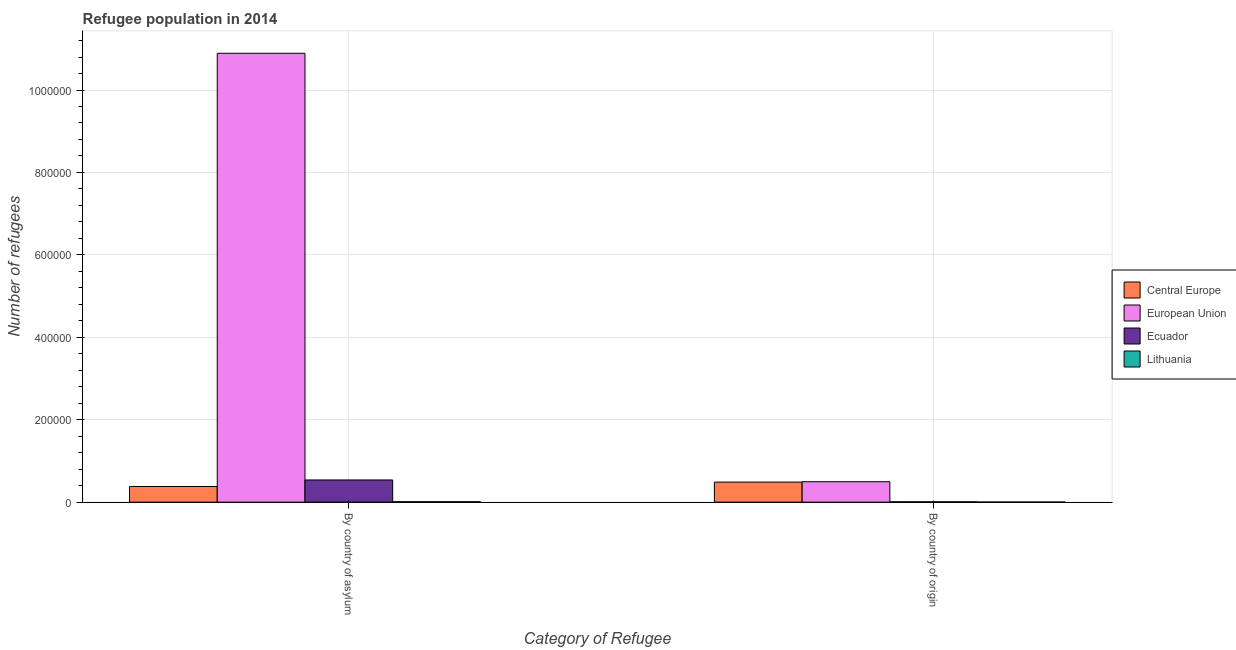How many groups of bars are there?
Your response must be concise. 2. Are the number of bars per tick equal to the number of legend labels?
Offer a terse response. Yes. Are the number of bars on each tick of the X-axis equal?
Your response must be concise. Yes. What is the label of the 2nd group of bars from the left?
Give a very brief answer. By country of origin. What is the number of refugees by country of asylum in Central Europe?
Make the answer very short. 3.80e+04. Across all countries, what is the maximum number of refugees by country of asylum?
Offer a very short reply. 1.09e+06. Across all countries, what is the minimum number of refugees by country of origin?
Give a very brief answer. 183. In which country was the number of refugees by country of asylum minimum?
Make the answer very short. Lithuania. What is the total number of refugees by country of origin in the graph?
Make the answer very short. 9.92e+04. What is the difference between the number of refugees by country of asylum in Central Europe and that in Lithuania?
Offer a very short reply. 3.70e+04. What is the difference between the number of refugees by country of origin in Ecuador and the number of refugees by country of asylum in Central Europe?
Your answer should be compact. -3.72e+04. What is the average number of refugees by country of asylum per country?
Provide a short and direct response. 2.95e+05. What is the difference between the number of refugees by country of asylum and number of refugees by country of origin in Lithuania?
Your answer should be very brief. 824. What is the ratio of the number of refugees by country of asylum in European Union to that in Central Europe?
Make the answer very short. 28.67. Is the number of refugees by country of origin in Central Europe less than that in European Union?
Your answer should be compact. Yes. What does the 1st bar from the left in By country of origin represents?
Your response must be concise. Central Europe. What does the 4th bar from the right in By country of asylum represents?
Provide a short and direct response. Central Europe. Are all the bars in the graph horizontal?
Offer a very short reply. No. How many countries are there in the graph?
Offer a terse response. 4. Are the values on the major ticks of Y-axis written in scientific E-notation?
Your answer should be very brief. No. Does the graph contain any zero values?
Provide a short and direct response. No. Does the graph contain grids?
Offer a terse response. Yes. What is the title of the graph?
Provide a succinct answer. Refugee population in 2014. What is the label or title of the X-axis?
Provide a succinct answer. Category of Refugee. What is the label or title of the Y-axis?
Your answer should be very brief. Number of refugees. What is the Number of refugees of Central Europe in By country of asylum?
Ensure brevity in your answer.  3.80e+04. What is the Number of refugees of European Union in By country of asylum?
Provide a short and direct response. 1.09e+06. What is the Number of refugees in Ecuador in By country of asylum?
Your answer should be compact. 5.38e+04. What is the Number of refugees of Lithuania in By country of asylum?
Offer a very short reply. 1007. What is the Number of refugees in Central Europe in By country of origin?
Your response must be concise. 4.87e+04. What is the Number of refugees of European Union in By country of origin?
Provide a short and direct response. 4.96e+04. What is the Number of refugees of Ecuador in By country of origin?
Make the answer very short. 805. What is the Number of refugees of Lithuania in By country of origin?
Make the answer very short. 183. Across all Category of Refugee, what is the maximum Number of refugees of Central Europe?
Offer a very short reply. 4.87e+04. Across all Category of Refugee, what is the maximum Number of refugees in European Union?
Give a very brief answer. 1.09e+06. Across all Category of Refugee, what is the maximum Number of refugees in Ecuador?
Offer a very short reply. 5.38e+04. Across all Category of Refugee, what is the maximum Number of refugees of Lithuania?
Your answer should be compact. 1007. Across all Category of Refugee, what is the minimum Number of refugees of Central Europe?
Keep it short and to the point. 3.80e+04. Across all Category of Refugee, what is the minimum Number of refugees of European Union?
Provide a succinct answer. 4.96e+04. Across all Category of Refugee, what is the minimum Number of refugees of Ecuador?
Offer a very short reply. 805. Across all Category of Refugee, what is the minimum Number of refugees in Lithuania?
Give a very brief answer. 183. What is the total Number of refugees of Central Europe in the graph?
Make the answer very short. 8.67e+04. What is the total Number of refugees in European Union in the graph?
Ensure brevity in your answer.  1.14e+06. What is the total Number of refugees in Ecuador in the graph?
Provide a short and direct response. 5.46e+04. What is the total Number of refugees of Lithuania in the graph?
Provide a short and direct response. 1190. What is the difference between the Number of refugees in Central Europe in By country of asylum and that in By country of origin?
Provide a short and direct response. -1.07e+04. What is the difference between the Number of refugees in European Union in By country of asylum and that in By country of origin?
Provide a short and direct response. 1.04e+06. What is the difference between the Number of refugees in Ecuador in By country of asylum and that in By country of origin?
Offer a very short reply. 5.30e+04. What is the difference between the Number of refugees of Lithuania in By country of asylum and that in By country of origin?
Your answer should be compact. 824. What is the difference between the Number of refugees in Central Europe in By country of asylum and the Number of refugees in European Union in By country of origin?
Ensure brevity in your answer.  -1.16e+04. What is the difference between the Number of refugees in Central Europe in By country of asylum and the Number of refugees in Ecuador in By country of origin?
Your response must be concise. 3.72e+04. What is the difference between the Number of refugees in Central Europe in By country of asylum and the Number of refugees in Lithuania in By country of origin?
Your answer should be very brief. 3.78e+04. What is the difference between the Number of refugees in European Union in By country of asylum and the Number of refugees in Ecuador in By country of origin?
Keep it short and to the point. 1.09e+06. What is the difference between the Number of refugees in European Union in By country of asylum and the Number of refugees in Lithuania in By country of origin?
Ensure brevity in your answer.  1.09e+06. What is the difference between the Number of refugees in Ecuador in By country of asylum and the Number of refugees in Lithuania in By country of origin?
Your answer should be very brief. 5.36e+04. What is the average Number of refugees of Central Europe per Category of Refugee?
Your response must be concise. 4.33e+04. What is the average Number of refugees in European Union per Category of Refugee?
Offer a terse response. 5.69e+05. What is the average Number of refugees of Ecuador per Category of Refugee?
Provide a short and direct response. 2.73e+04. What is the average Number of refugees of Lithuania per Category of Refugee?
Provide a short and direct response. 595. What is the difference between the Number of refugees of Central Europe and Number of refugees of European Union in By country of asylum?
Your response must be concise. -1.05e+06. What is the difference between the Number of refugees in Central Europe and Number of refugees in Ecuador in By country of asylum?
Offer a very short reply. -1.58e+04. What is the difference between the Number of refugees of Central Europe and Number of refugees of Lithuania in By country of asylum?
Your answer should be very brief. 3.70e+04. What is the difference between the Number of refugees in European Union and Number of refugees in Ecuador in By country of asylum?
Ensure brevity in your answer.  1.04e+06. What is the difference between the Number of refugees of European Union and Number of refugees of Lithuania in By country of asylum?
Make the answer very short. 1.09e+06. What is the difference between the Number of refugees of Ecuador and Number of refugees of Lithuania in By country of asylum?
Keep it short and to the point. 5.28e+04. What is the difference between the Number of refugees of Central Europe and Number of refugees of European Union in By country of origin?
Make the answer very short. -897. What is the difference between the Number of refugees in Central Europe and Number of refugees in Ecuador in By country of origin?
Ensure brevity in your answer.  4.79e+04. What is the difference between the Number of refugees in Central Europe and Number of refugees in Lithuania in By country of origin?
Provide a succinct answer. 4.85e+04. What is the difference between the Number of refugees in European Union and Number of refugees in Ecuador in By country of origin?
Make the answer very short. 4.88e+04. What is the difference between the Number of refugees of European Union and Number of refugees of Lithuania in By country of origin?
Provide a succinct answer. 4.94e+04. What is the difference between the Number of refugees of Ecuador and Number of refugees of Lithuania in By country of origin?
Your answer should be compact. 622. What is the ratio of the Number of refugees in Central Europe in By country of asylum to that in By country of origin?
Ensure brevity in your answer.  0.78. What is the ratio of the Number of refugees in European Union in By country of asylum to that in By country of origin?
Keep it short and to the point. 21.97. What is the ratio of the Number of refugees of Ecuador in By country of asylum to that in By country of origin?
Ensure brevity in your answer.  66.85. What is the ratio of the Number of refugees of Lithuania in By country of asylum to that in By country of origin?
Keep it short and to the point. 5.5. What is the difference between the highest and the second highest Number of refugees in Central Europe?
Your answer should be very brief. 1.07e+04. What is the difference between the highest and the second highest Number of refugees in European Union?
Provide a short and direct response. 1.04e+06. What is the difference between the highest and the second highest Number of refugees in Ecuador?
Your answer should be compact. 5.30e+04. What is the difference between the highest and the second highest Number of refugees in Lithuania?
Give a very brief answer. 824. What is the difference between the highest and the lowest Number of refugees of Central Europe?
Your answer should be very brief. 1.07e+04. What is the difference between the highest and the lowest Number of refugees in European Union?
Your answer should be very brief. 1.04e+06. What is the difference between the highest and the lowest Number of refugees of Ecuador?
Your answer should be very brief. 5.30e+04. What is the difference between the highest and the lowest Number of refugees in Lithuania?
Offer a very short reply. 824. 